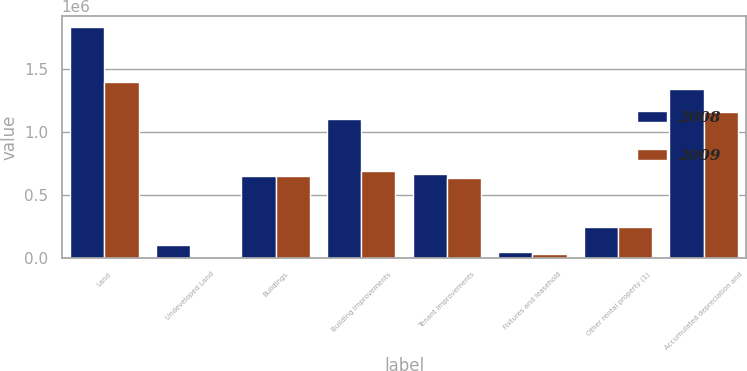<chart> <loc_0><loc_0><loc_500><loc_500><stacked_bar_chart><ecel><fcel>Land<fcel>Undeveloped Land<fcel>Buildings<fcel>Building improvements<fcel>Tenant improvements<fcel>Fixtures and leasehold<fcel>Other rental property (1)<fcel>Accumulated depreciation and<nl><fcel>2008<fcel>1.83137e+06<fcel>106054<fcel>651712<fcel>1.1038e+06<fcel>669540<fcel>48008<fcel>246217<fcel>1.34315e+06<nl><fcel>2009<fcel>1.39446e+06<fcel>1185<fcel>651712<fcel>692040<fcel>633883<fcel>35377<fcel>245452<fcel>1.15966e+06<nl></chart> 